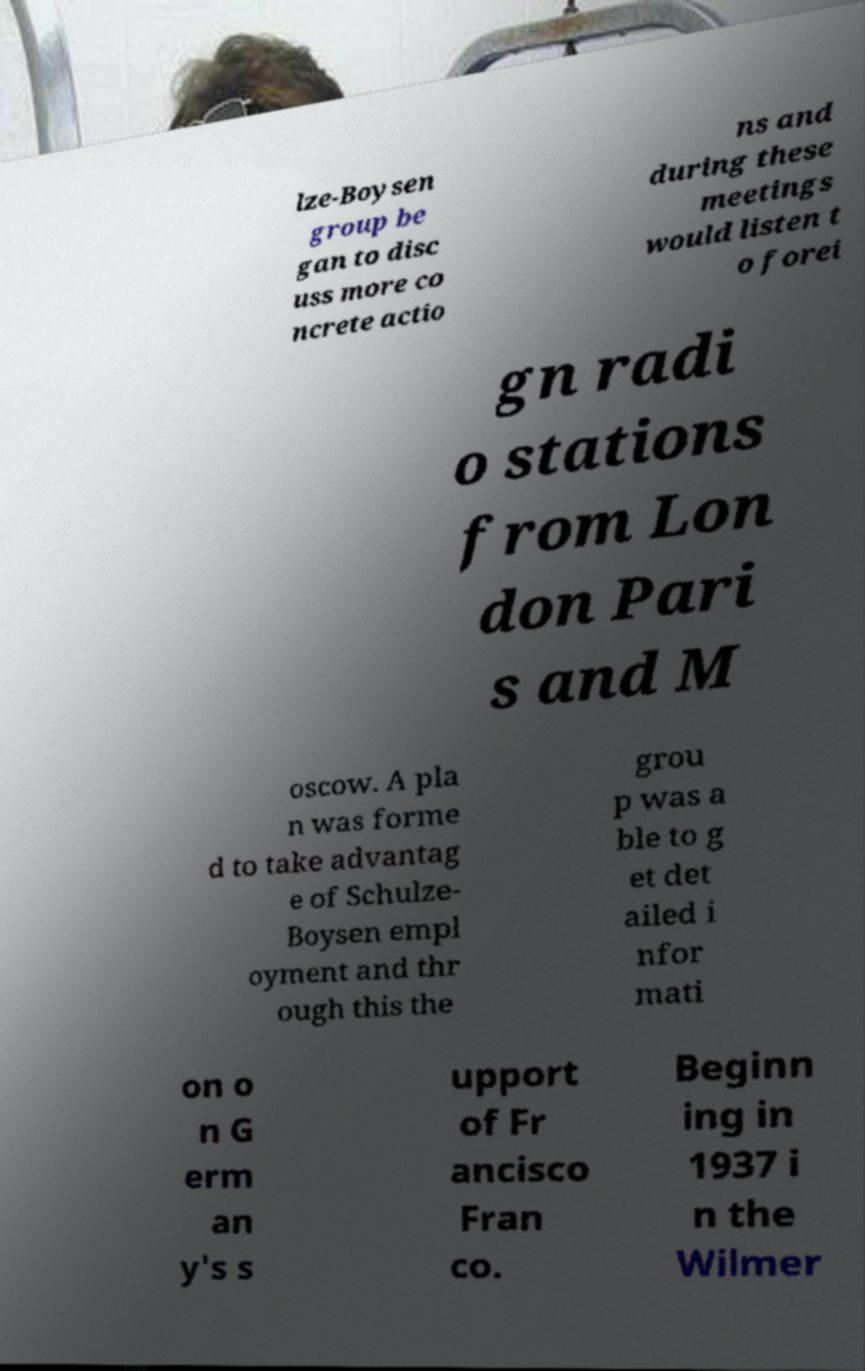Could you assist in decoding the text presented in this image and type it out clearly? lze-Boysen group be gan to disc uss more co ncrete actio ns and during these meetings would listen t o forei gn radi o stations from Lon don Pari s and M oscow. A pla n was forme d to take advantag e of Schulze- Boysen empl oyment and thr ough this the grou p was a ble to g et det ailed i nfor mati on o n G erm an y's s upport of Fr ancisco Fran co. Beginn ing in 1937 i n the Wilmer 